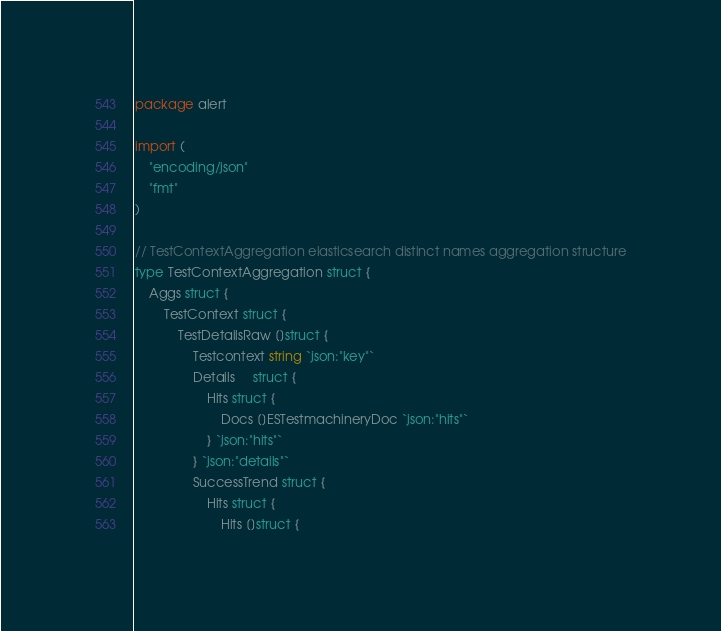Convert code to text. <code><loc_0><loc_0><loc_500><loc_500><_Go_>package alert

import (
	"encoding/json"
	"fmt"
)

// TestContextAggregation elasticsearch distinct names aggregation structure
type TestContextAggregation struct {
	Aggs struct {
		TestContext struct {
			TestDetailsRaw []struct {
				Testcontext string `json:"key"`
				Details     struct {
					Hits struct {
						Docs []ESTestmachineryDoc `json:"hits"`
					} `json:"hits"`
				} `json:"details"`
				SuccessTrend struct {
					Hits struct {
						Hits []struct {</code> 